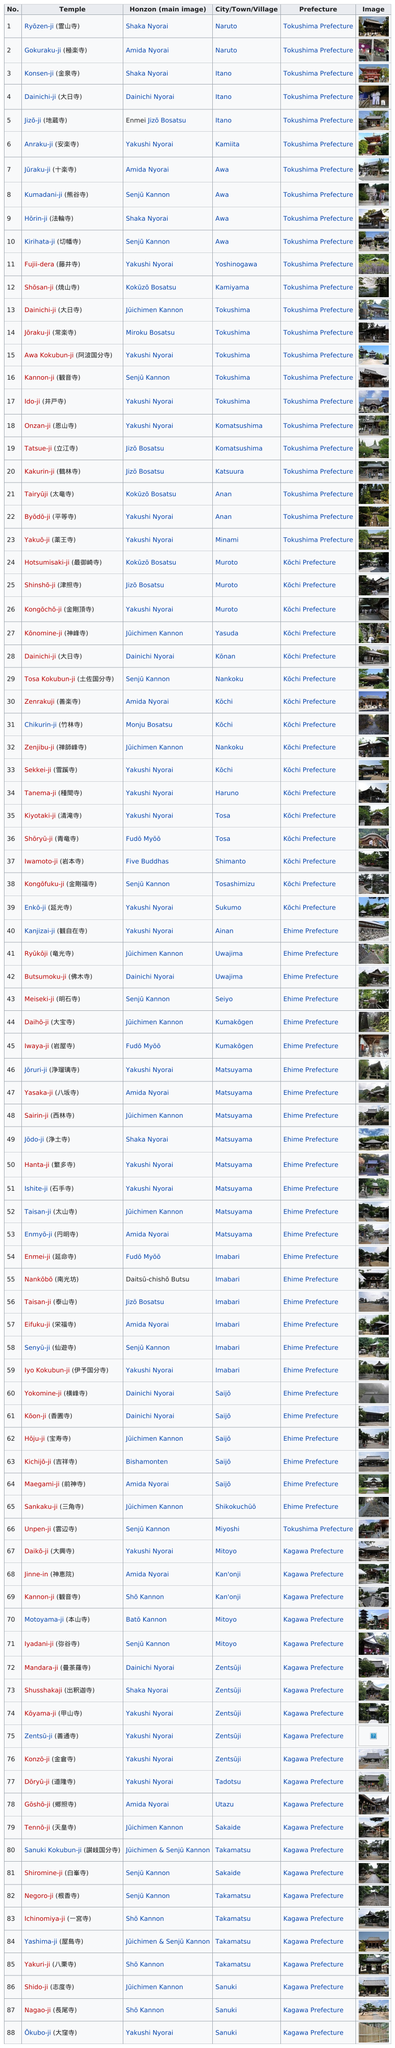Indicate a few pertinent items in this graphic. The table contains 88 listed temples. There are three temples in the city of Muroto. There are 16 temples in Kochi Prefecture. The Gokuraku-ji temple is located in the same city as the Ryōzen-ji (霊山寺) temple. What is the difference in the number of temples between Imabari and Matsuyama?" is a question asking for a comparison between two places. 